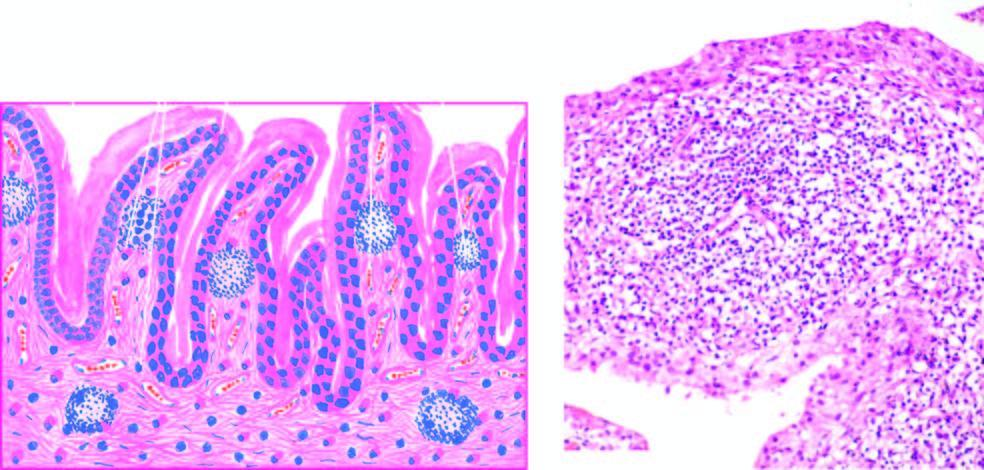re chematic mechanisms villous hypertrophy of the synovium and marked mononuclear inflammatory cell infiltrate in synovial membrane with formation of lymphoid follicles at places?
Answer the question using a single word or phrase. No 